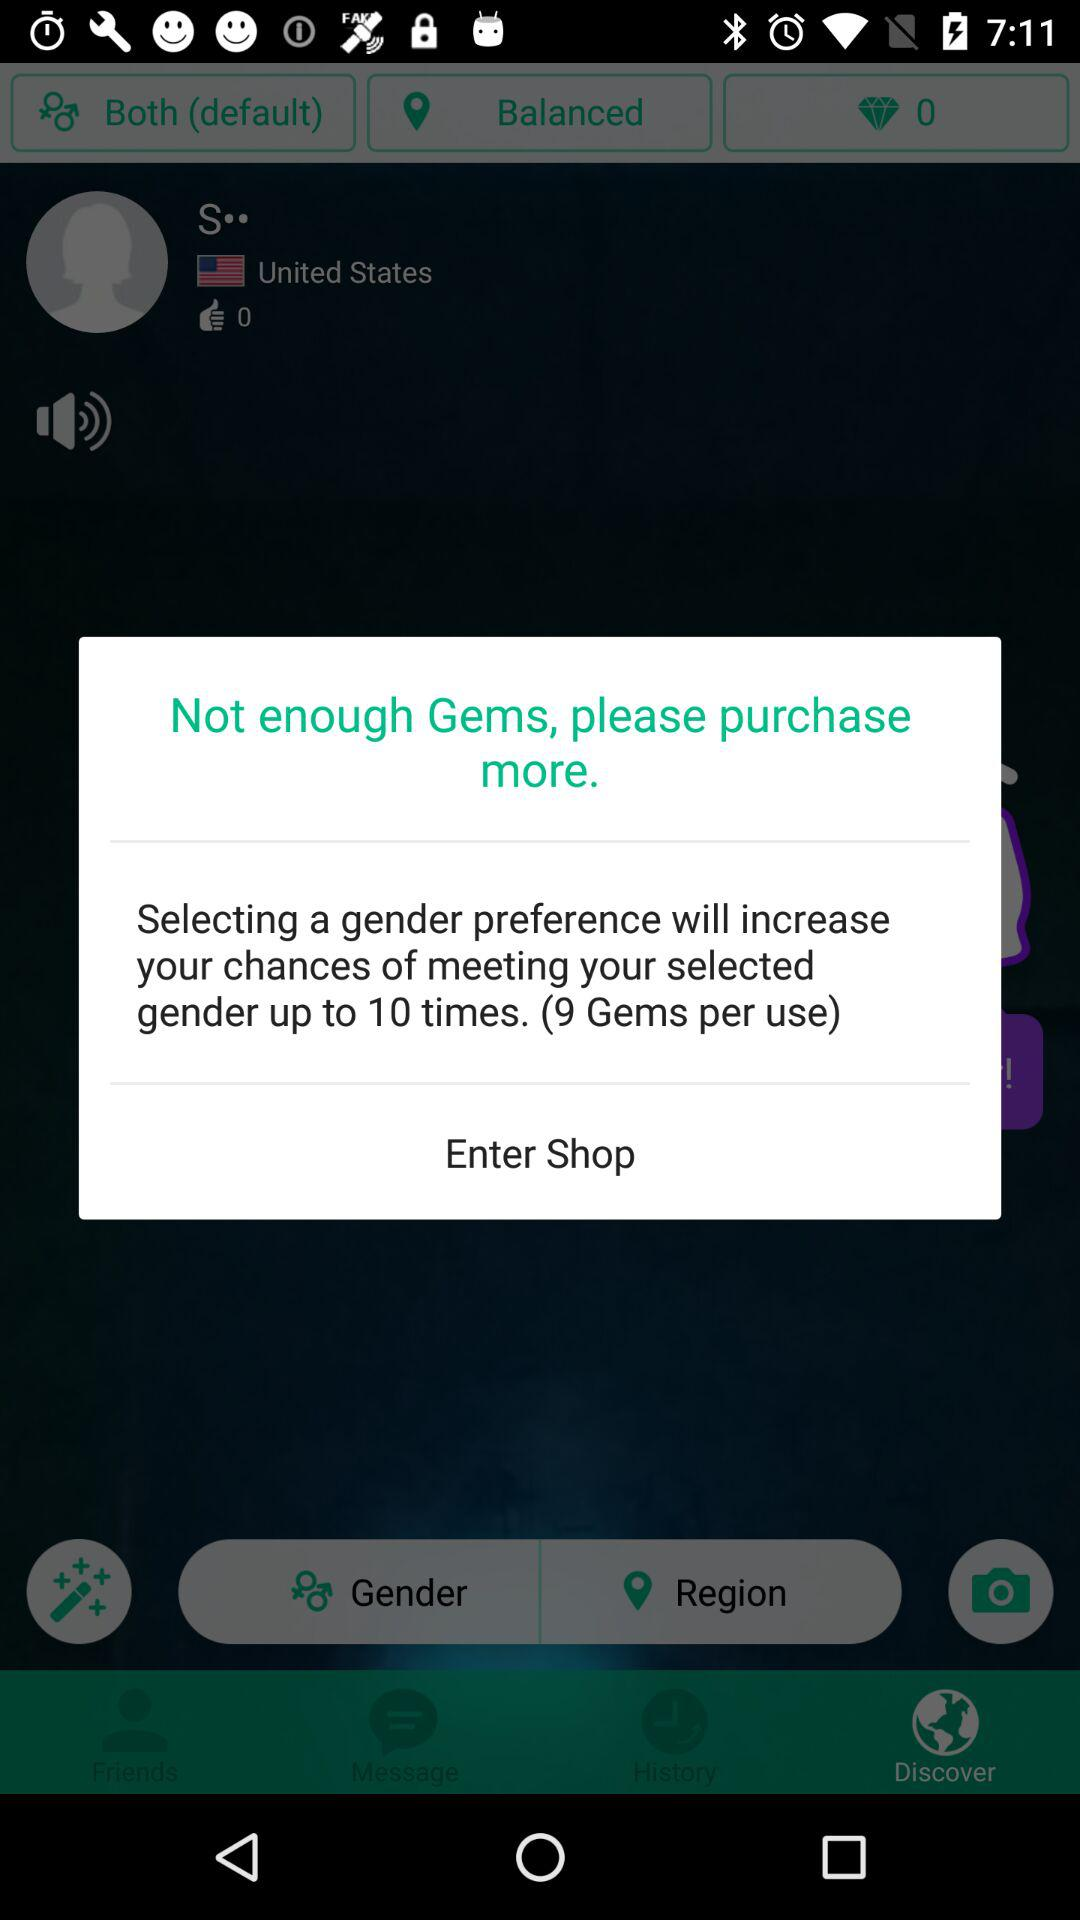How many more gems are needed to purchase gender preference?
Answer the question using a single word or phrase. 9 